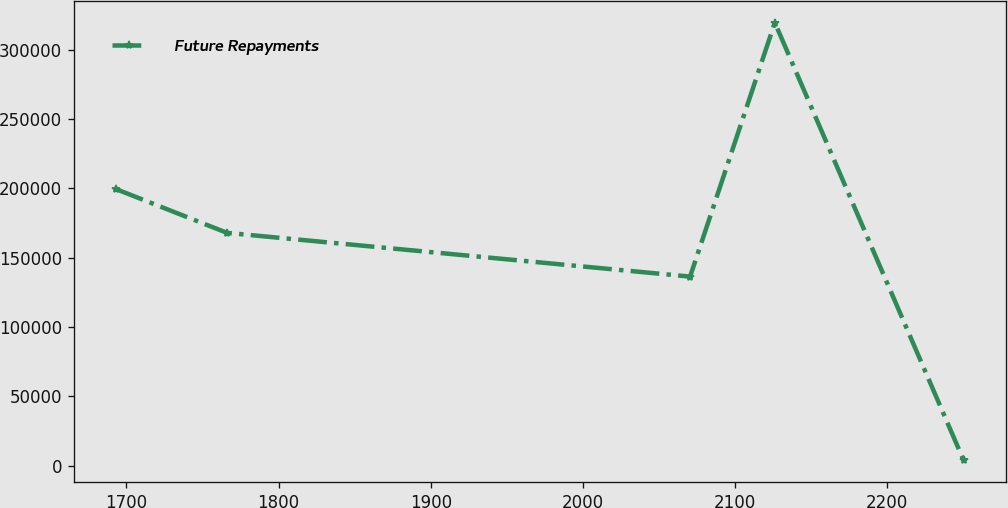Convert chart. <chart><loc_0><loc_0><loc_500><loc_500><line_chart><ecel><fcel>Future Repayments<nl><fcel>1693.14<fcel>199508<nl><fcel>1766.12<fcel>167962<nl><fcel>2070.38<fcel>136417<nl><fcel>2126.07<fcel>319551<nl><fcel>2250.07<fcel>4095.97<nl></chart> 